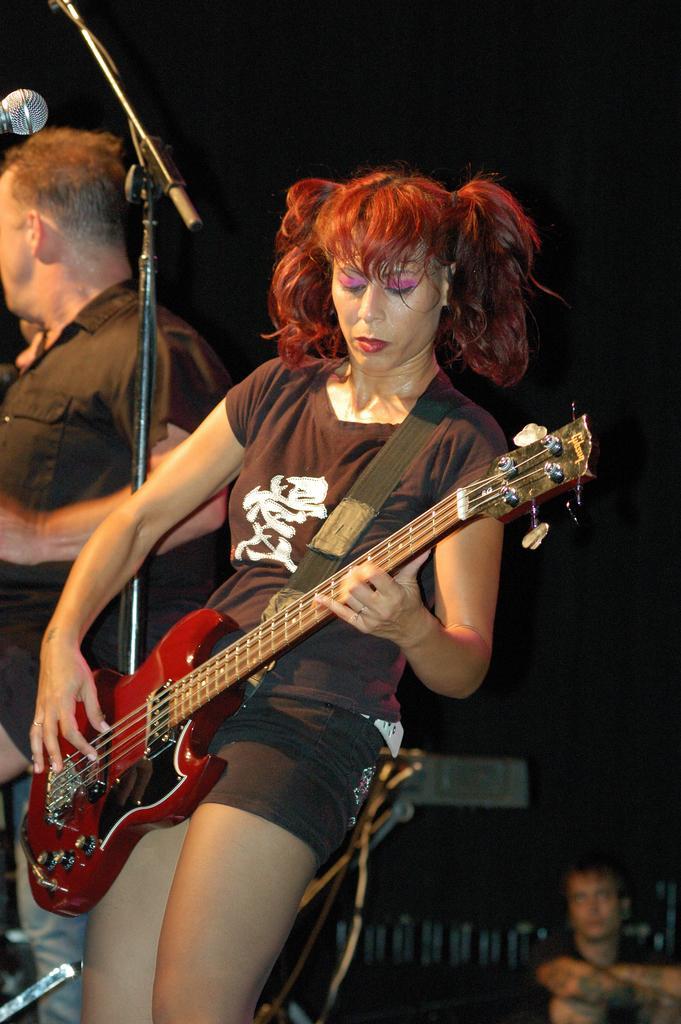Can you describe this image briefly? In this picture we can see woman standing holding guitar in his hand and playing and beside to her we can see man, mic stand, mic and at back of her man is sitting and in background it is blurry and dark. 